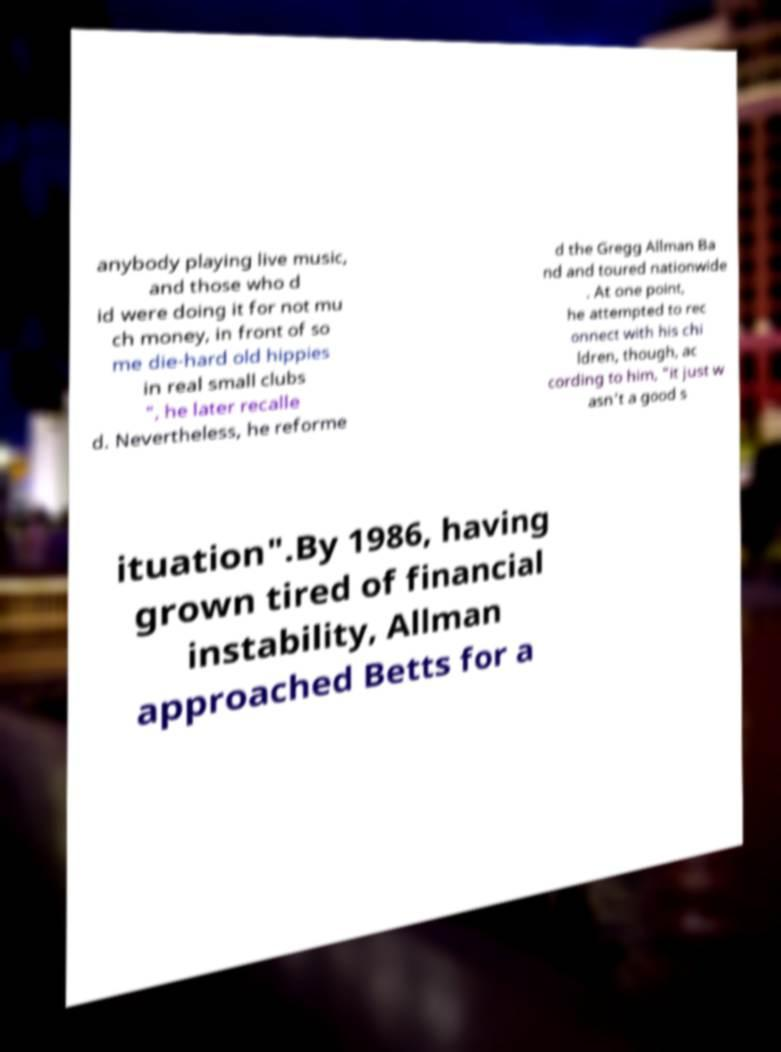I need the written content from this picture converted into text. Can you do that? anybody playing live music, and those who d id were doing it for not mu ch money, in front of so me die-hard old hippies in real small clubs ", he later recalle d. Nevertheless, he reforme d the Gregg Allman Ba nd and toured nationwide . At one point, he attempted to rec onnect with his chi ldren, though, ac cording to him, "it just w asn't a good s ituation".By 1986, having grown tired of financial instability, Allman approached Betts for a 